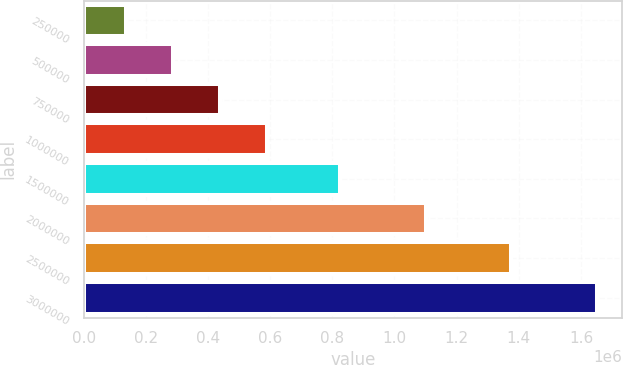Convert chart. <chart><loc_0><loc_0><loc_500><loc_500><bar_chart><fcel>250000<fcel>500000<fcel>750000<fcel>1000000<fcel>1500000<fcel>2000000<fcel>2500000<fcel>3000000<nl><fcel>137500<fcel>288750<fcel>440000<fcel>591250<fcel>825000<fcel>1.1e+06<fcel>1.375e+06<fcel>1.65e+06<nl></chart> 